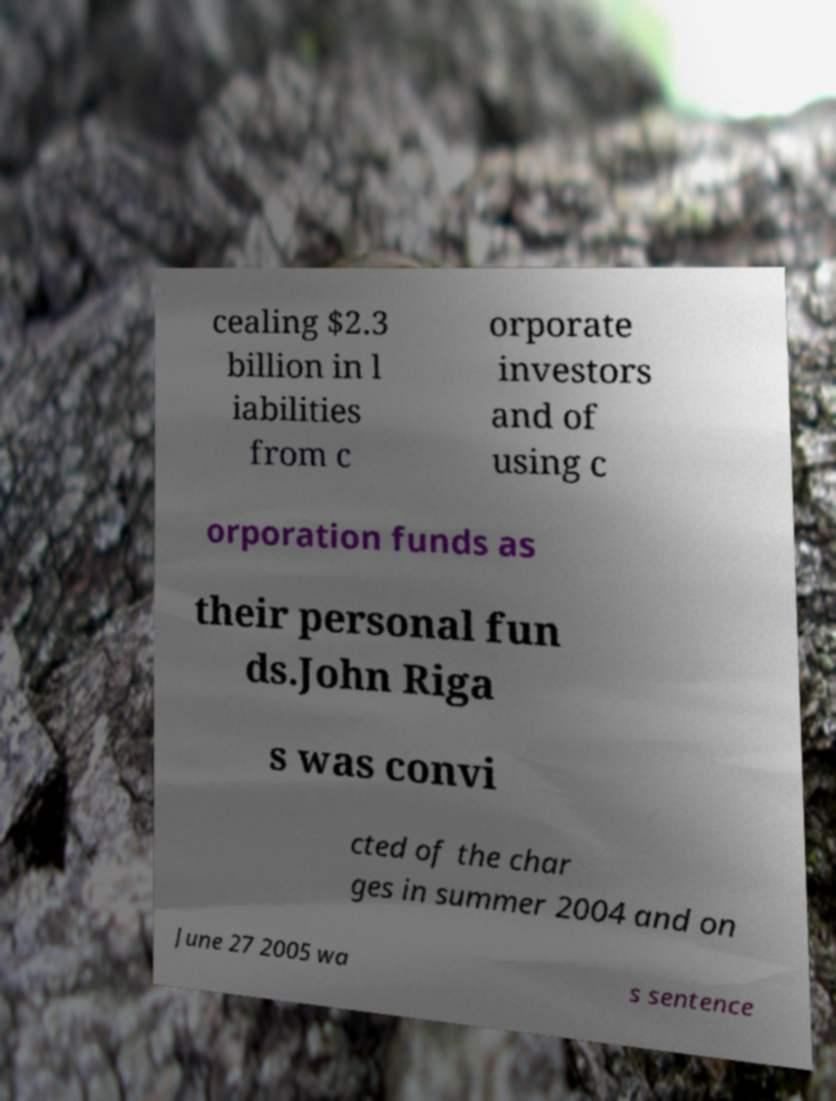Please read and relay the text visible in this image. What does it say? cealing $2.3 billion in l iabilities from c orporate investors and of using c orporation funds as their personal fun ds.John Riga s was convi cted of the char ges in summer 2004 and on June 27 2005 wa s sentence 